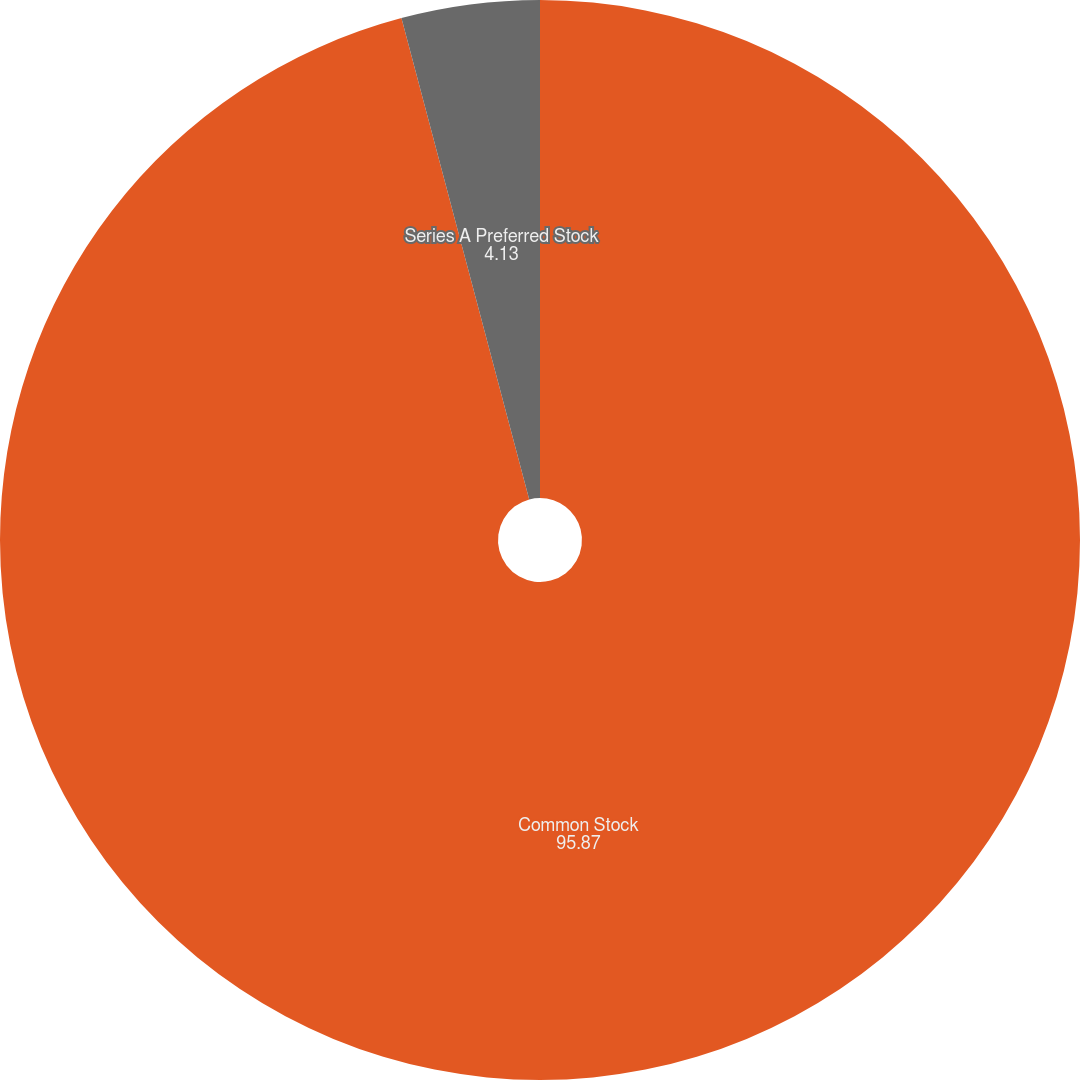Convert chart to OTSL. <chart><loc_0><loc_0><loc_500><loc_500><pie_chart><fcel>Common Stock<fcel>Series A Preferred Stock<nl><fcel>95.87%<fcel>4.13%<nl></chart> 